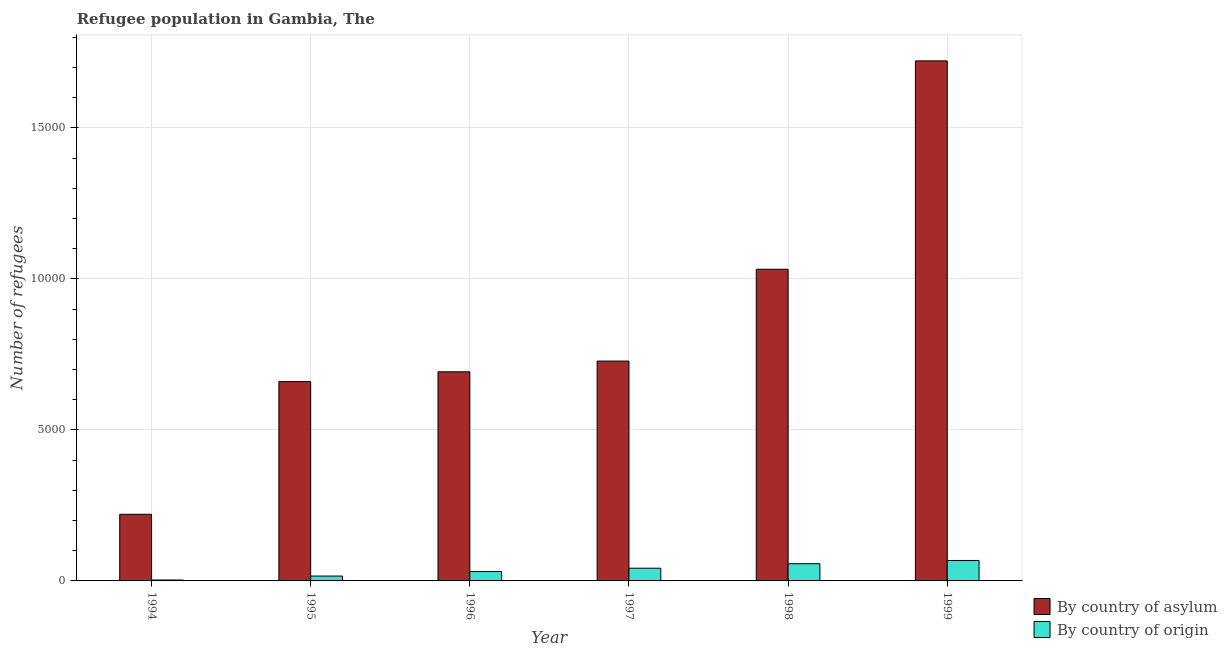How many bars are there on the 6th tick from the right?
Your answer should be compact. 2. What is the label of the 4th group of bars from the left?
Make the answer very short. 1997. What is the number of refugees by country of origin in 1998?
Give a very brief answer. 570. Across all years, what is the maximum number of refugees by country of asylum?
Keep it short and to the point. 1.72e+04. Across all years, what is the minimum number of refugees by country of asylum?
Offer a very short reply. 2206. In which year was the number of refugees by country of origin maximum?
Offer a very short reply. 1999. What is the total number of refugees by country of origin in the graph?
Offer a terse response. 2169. What is the difference between the number of refugees by country of asylum in 1996 and that in 1997?
Offer a terse response. -355. What is the difference between the number of refugees by country of asylum in 1998 and the number of refugees by country of origin in 1999?
Your answer should be compact. -6899. What is the average number of refugees by country of asylum per year?
Offer a terse response. 8424.5. In the year 1998, what is the difference between the number of refugees by country of origin and number of refugees by country of asylum?
Make the answer very short. 0. What is the ratio of the number of refugees by country of origin in 1997 to that in 1999?
Provide a succinct answer. 0.62. What is the difference between the highest and the second highest number of refugees by country of origin?
Your response must be concise. 107. What is the difference between the highest and the lowest number of refugees by country of asylum?
Your answer should be very brief. 1.50e+04. In how many years, is the number of refugees by country of origin greater than the average number of refugees by country of origin taken over all years?
Offer a very short reply. 3. What does the 1st bar from the left in 1995 represents?
Your response must be concise. By country of asylum. What does the 2nd bar from the right in 1999 represents?
Provide a succinct answer. By country of asylum. How many years are there in the graph?
Your response must be concise. 6. What is the difference between two consecutive major ticks on the Y-axis?
Offer a very short reply. 5000. Does the graph contain any zero values?
Your response must be concise. No. How are the legend labels stacked?
Your answer should be compact. Vertical. What is the title of the graph?
Your response must be concise. Refugee population in Gambia, The. Does "Banks" appear as one of the legend labels in the graph?
Offer a terse response. No. What is the label or title of the X-axis?
Give a very brief answer. Year. What is the label or title of the Y-axis?
Offer a terse response. Number of refugees. What is the Number of refugees in By country of asylum in 1994?
Ensure brevity in your answer.  2206. What is the Number of refugees in By country of origin in 1994?
Offer a very short reply. 30. What is the Number of refugees in By country of asylum in 1995?
Your response must be concise. 6599. What is the Number of refugees in By country of origin in 1995?
Ensure brevity in your answer.  161. What is the Number of refugees in By country of asylum in 1996?
Your response must be concise. 6924. What is the Number of refugees of By country of origin in 1996?
Your answer should be very brief. 310. What is the Number of refugees of By country of asylum in 1997?
Your answer should be compact. 7279. What is the Number of refugees of By country of origin in 1997?
Your response must be concise. 421. What is the Number of refugees of By country of asylum in 1998?
Offer a very short reply. 1.03e+04. What is the Number of refugees of By country of origin in 1998?
Make the answer very short. 570. What is the Number of refugees of By country of asylum in 1999?
Your answer should be very brief. 1.72e+04. What is the Number of refugees in By country of origin in 1999?
Provide a succinct answer. 677. Across all years, what is the maximum Number of refugees in By country of asylum?
Provide a short and direct response. 1.72e+04. Across all years, what is the maximum Number of refugees in By country of origin?
Your response must be concise. 677. Across all years, what is the minimum Number of refugees in By country of asylum?
Give a very brief answer. 2206. Across all years, what is the minimum Number of refugees of By country of origin?
Give a very brief answer. 30. What is the total Number of refugees of By country of asylum in the graph?
Offer a very short reply. 5.05e+04. What is the total Number of refugees in By country of origin in the graph?
Ensure brevity in your answer.  2169. What is the difference between the Number of refugees of By country of asylum in 1994 and that in 1995?
Your answer should be very brief. -4393. What is the difference between the Number of refugees of By country of origin in 1994 and that in 1995?
Keep it short and to the point. -131. What is the difference between the Number of refugees of By country of asylum in 1994 and that in 1996?
Offer a very short reply. -4718. What is the difference between the Number of refugees in By country of origin in 1994 and that in 1996?
Your answer should be very brief. -280. What is the difference between the Number of refugees in By country of asylum in 1994 and that in 1997?
Offer a very short reply. -5073. What is the difference between the Number of refugees in By country of origin in 1994 and that in 1997?
Ensure brevity in your answer.  -391. What is the difference between the Number of refugees in By country of asylum in 1994 and that in 1998?
Provide a short and direct response. -8114. What is the difference between the Number of refugees of By country of origin in 1994 and that in 1998?
Your answer should be compact. -540. What is the difference between the Number of refugees of By country of asylum in 1994 and that in 1999?
Give a very brief answer. -1.50e+04. What is the difference between the Number of refugees of By country of origin in 1994 and that in 1999?
Provide a succinct answer. -647. What is the difference between the Number of refugees in By country of asylum in 1995 and that in 1996?
Your response must be concise. -325. What is the difference between the Number of refugees of By country of origin in 1995 and that in 1996?
Your answer should be compact. -149. What is the difference between the Number of refugees in By country of asylum in 1995 and that in 1997?
Offer a terse response. -680. What is the difference between the Number of refugees of By country of origin in 1995 and that in 1997?
Provide a succinct answer. -260. What is the difference between the Number of refugees of By country of asylum in 1995 and that in 1998?
Your response must be concise. -3721. What is the difference between the Number of refugees of By country of origin in 1995 and that in 1998?
Make the answer very short. -409. What is the difference between the Number of refugees in By country of asylum in 1995 and that in 1999?
Provide a short and direct response. -1.06e+04. What is the difference between the Number of refugees of By country of origin in 1995 and that in 1999?
Make the answer very short. -516. What is the difference between the Number of refugees of By country of asylum in 1996 and that in 1997?
Give a very brief answer. -355. What is the difference between the Number of refugees in By country of origin in 1996 and that in 1997?
Your answer should be very brief. -111. What is the difference between the Number of refugees of By country of asylum in 1996 and that in 1998?
Give a very brief answer. -3396. What is the difference between the Number of refugees in By country of origin in 1996 and that in 1998?
Offer a terse response. -260. What is the difference between the Number of refugees in By country of asylum in 1996 and that in 1999?
Your answer should be compact. -1.03e+04. What is the difference between the Number of refugees in By country of origin in 1996 and that in 1999?
Your response must be concise. -367. What is the difference between the Number of refugees of By country of asylum in 1997 and that in 1998?
Your response must be concise. -3041. What is the difference between the Number of refugees of By country of origin in 1997 and that in 1998?
Your response must be concise. -149. What is the difference between the Number of refugees in By country of asylum in 1997 and that in 1999?
Provide a succinct answer. -9940. What is the difference between the Number of refugees of By country of origin in 1997 and that in 1999?
Provide a short and direct response. -256. What is the difference between the Number of refugees in By country of asylum in 1998 and that in 1999?
Make the answer very short. -6899. What is the difference between the Number of refugees of By country of origin in 1998 and that in 1999?
Your answer should be compact. -107. What is the difference between the Number of refugees of By country of asylum in 1994 and the Number of refugees of By country of origin in 1995?
Offer a terse response. 2045. What is the difference between the Number of refugees in By country of asylum in 1994 and the Number of refugees in By country of origin in 1996?
Your response must be concise. 1896. What is the difference between the Number of refugees of By country of asylum in 1994 and the Number of refugees of By country of origin in 1997?
Your response must be concise. 1785. What is the difference between the Number of refugees in By country of asylum in 1994 and the Number of refugees in By country of origin in 1998?
Keep it short and to the point. 1636. What is the difference between the Number of refugees in By country of asylum in 1994 and the Number of refugees in By country of origin in 1999?
Provide a short and direct response. 1529. What is the difference between the Number of refugees in By country of asylum in 1995 and the Number of refugees in By country of origin in 1996?
Provide a succinct answer. 6289. What is the difference between the Number of refugees of By country of asylum in 1995 and the Number of refugees of By country of origin in 1997?
Provide a succinct answer. 6178. What is the difference between the Number of refugees of By country of asylum in 1995 and the Number of refugees of By country of origin in 1998?
Provide a succinct answer. 6029. What is the difference between the Number of refugees of By country of asylum in 1995 and the Number of refugees of By country of origin in 1999?
Your answer should be compact. 5922. What is the difference between the Number of refugees of By country of asylum in 1996 and the Number of refugees of By country of origin in 1997?
Your response must be concise. 6503. What is the difference between the Number of refugees in By country of asylum in 1996 and the Number of refugees in By country of origin in 1998?
Offer a terse response. 6354. What is the difference between the Number of refugees in By country of asylum in 1996 and the Number of refugees in By country of origin in 1999?
Your response must be concise. 6247. What is the difference between the Number of refugees in By country of asylum in 1997 and the Number of refugees in By country of origin in 1998?
Offer a terse response. 6709. What is the difference between the Number of refugees of By country of asylum in 1997 and the Number of refugees of By country of origin in 1999?
Give a very brief answer. 6602. What is the difference between the Number of refugees of By country of asylum in 1998 and the Number of refugees of By country of origin in 1999?
Ensure brevity in your answer.  9643. What is the average Number of refugees of By country of asylum per year?
Your answer should be compact. 8424.5. What is the average Number of refugees of By country of origin per year?
Make the answer very short. 361.5. In the year 1994, what is the difference between the Number of refugees of By country of asylum and Number of refugees of By country of origin?
Offer a terse response. 2176. In the year 1995, what is the difference between the Number of refugees of By country of asylum and Number of refugees of By country of origin?
Ensure brevity in your answer.  6438. In the year 1996, what is the difference between the Number of refugees of By country of asylum and Number of refugees of By country of origin?
Offer a terse response. 6614. In the year 1997, what is the difference between the Number of refugees of By country of asylum and Number of refugees of By country of origin?
Your answer should be compact. 6858. In the year 1998, what is the difference between the Number of refugees in By country of asylum and Number of refugees in By country of origin?
Keep it short and to the point. 9750. In the year 1999, what is the difference between the Number of refugees in By country of asylum and Number of refugees in By country of origin?
Offer a very short reply. 1.65e+04. What is the ratio of the Number of refugees of By country of asylum in 1994 to that in 1995?
Offer a terse response. 0.33. What is the ratio of the Number of refugees of By country of origin in 1994 to that in 1995?
Your answer should be very brief. 0.19. What is the ratio of the Number of refugees of By country of asylum in 1994 to that in 1996?
Provide a succinct answer. 0.32. What is the ratio of the Number of refugees in By country of origin in 1994 to that in 1996?
Offer a terse response. 0.1. What is the ratio of the Number of refugees of By country of asylum in 1994 to that in 1997?
Make the answer very short. 0.3. What is the ratio of the Number of refugees of By country of origin in 1994 to that in 1997?
Provide a short and direct response. 0.07. What is the ratio of the Number of refugees of By country of asylum in 1994 to that in 1998?
Provide a short and direct response. 0.21. What is the ratio of the Number of refugees of By country of origin in 1994 to that in 1998?
Provide a short and direct response. 0.05. What is the ratio of the Number of refugees of By country of asylum in 1994 to that in 1999?
Give a very brief answer. 0.13. What is the ratio of the Number of refugees in By country of origin in 1994 to that in 1999?
Offer a very short reply. 0.04. What is the ratio of the Number of refugees in By country of asylum in 1995 to that in 1996?
Your response must be concise. 0.95. What is the ratio of the Number of refugees of By country of origin in 1995 to that in 1996?
Your answer should be compact. 0.52. What is the ratio of the Number of refugees of By country of asylum in 1995 to that in 1997?
Give a very brief answer. 0.91. What is the ratio of the Number of refugees in By country of origin in 1995 to that in 1997?
Offer a terse response. 0.38. What is the ratio of the Number of refugees of By country of asylum in 1995 to that in 1998?
Your answer should be very brief. 0.64. What is the ratio of the Number of refugees in By country of origin in 1995 to that in 1998?
Keep it short and to the point. 0.28. What is the ratio of the Number of refugees of By country of asylum in 1995 to that in 1999?
Your response must be concise. 0.38. What is the ratio of the Number of refugees in By country of origin in 1995 to that in 1999?
Ensure brevity in your answer.  0.24. What is the ratio of the Number of refugees in By country of asylum in 1996 to that in 1997?
Ensure brevity in your answer.  0.95. What is the ratio of the Number of refugees of By country of origin in 1996 to that in 1997?
Offer a very short reply. 0.74. What is the ratio of the Number of refugees of By country of asylum in 1996 to that in 1998?
Your answer should be compact. 0.67. What is the ratio of the Number of refugees in By country of origin in 1996 to that in 1998?
Offer a very short reply. 0.54. What is the ratio of the Number of refugees of By country of asylum in 1996 to that in 1999?
Your answer should be compact. 0.4. What is the ratio of the Number of refugees in By country of origin in 1996 to that in 1999?
Make the answer very short. 0.46. What is the ratio of the Number of refugees of By country of asylum in 1997 to that in 1998?
Offer a very short reply. 0.71. What is the ratio of the Number of refugees of By country of origin in 1997 to that in 1998?
Your answer should be compact. 0.74. What is the ratio of the Number of refugees in By country of asylum in 1997 to that in 1999?
Keep it short and to the point. 0.42. What is the ratio of the Number of refugees of By country of origin in 1997 to that in 1999?
Make the answer very short. 0.62. What is the ratio of the Number of refugees of By country of asylum in 1998 to that in 1999?
Make the answer very short. 0.6. What is the ratio of the Number of refugees of By country of origin in 1998 to that in 1999?
Offer a terse response. 0.84. What is the difference between the highest and the second highest Number of refugees in By country of asylum?
Give a very brief answer. 6899. What is the difference between the highest and the second highest Number of refugees in By country of origin?
Ensure brevity in your answer.  107. What is the difference between the highest and the lowest Number of refugees in By country of asylum?
Keep it short and to the point. 1.50e+04. What is the difference between the highest and the lowest Number of refugees in By country of origin?
Offer a terse response. 647. 